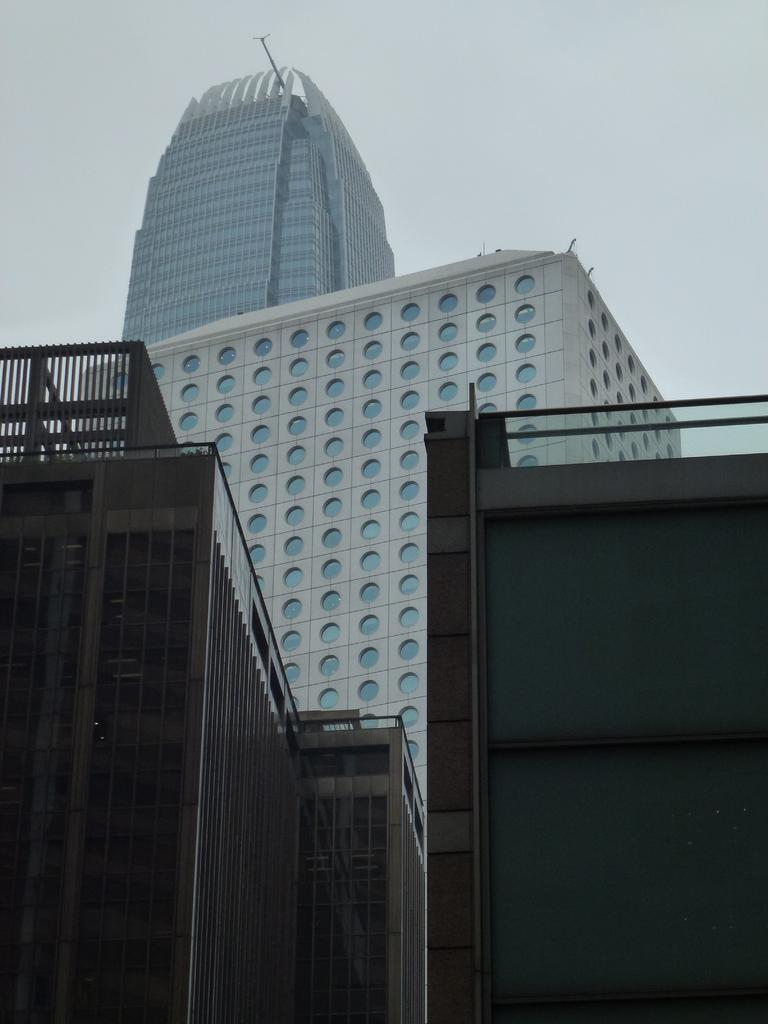What type of structures can be seen in the image? There are buildings in the image. Where are the buildings located in relation to the image? The buildings are in the foreground of the image. What can be seen in the background of the image? The sky is visible in the background of the image. What type of flowers are growing on the buildings in the image? There are no flowers visible on the buildings in the image. 